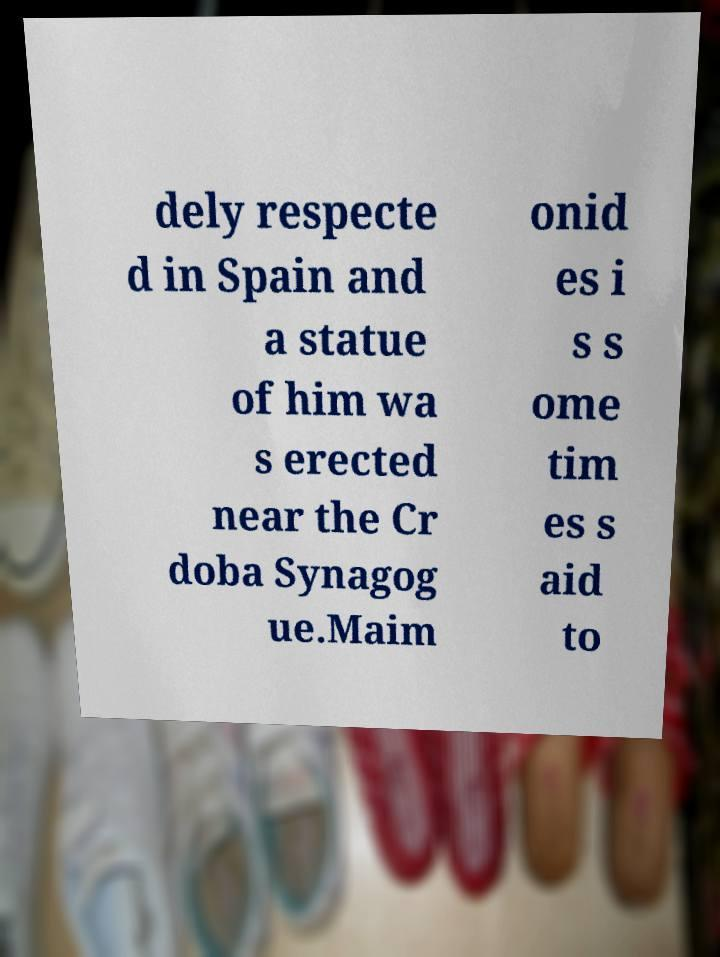Can you accurately transcribe the text from the provided image for me? dely respecte d in Spain and a statue of him wa s erected near the Cr doba Synagog ue.Maim onid es i s s ome tim es s aid to 